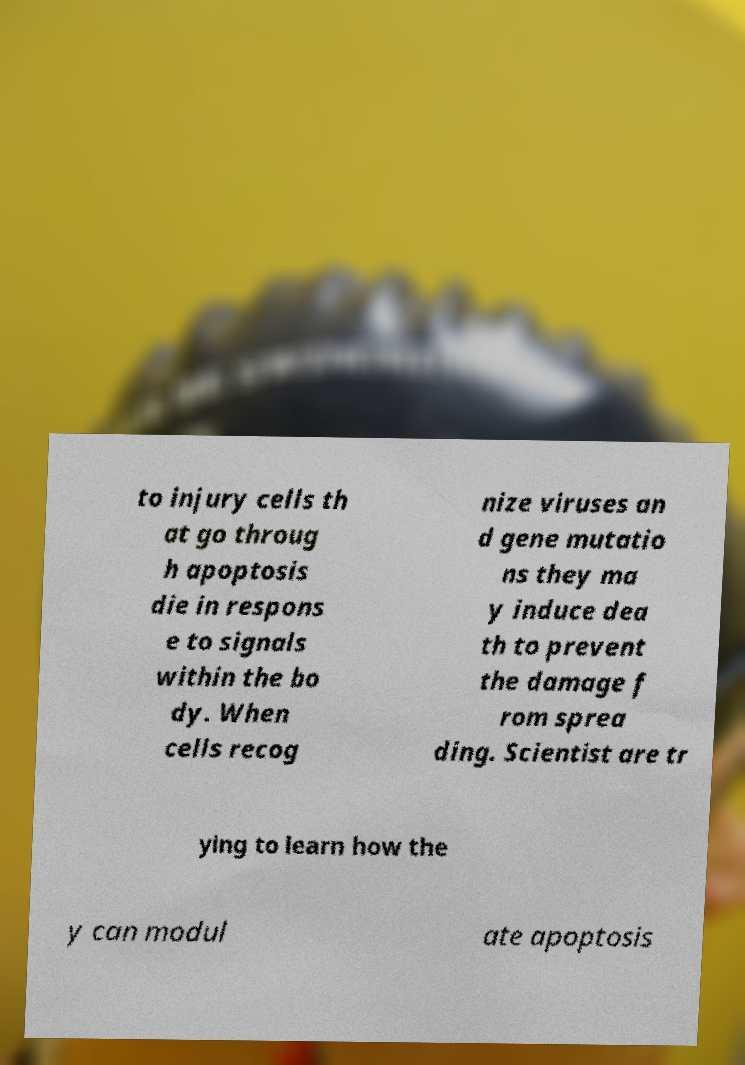Please identify and transcribe the text found in this image. to injury cells th at go throug h apoptosis die in respons e to signals within the bo dy. When cells recog nize viruses an d gene mutatio ns they ma y induce dea th to prevent the damage f rom sprea ding. Scientist are tr ying to learn how the y can modul ate apoptosis 